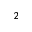<formula> <loc_0><loc_0><loc_500><loc_500>^ { 2 }</formula> 